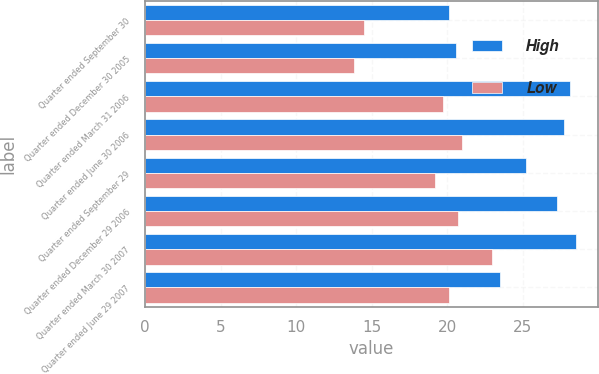Convert chart to OTSL. <chart><loc_0><loc_0><loc_500><loc_500><stacked_bar_chart><ecel><fcel>Quarter ended September 30<fcel>Quarter ended December 30 2005<fcel>Quarter ended March 31 2006<fcel>Quarter ended June 30 2006<fcel>Quarter ended September 29<fcel>Quarter ended December 29 2006<fcel>Quarter ended March 30 2007<fcel>Quarter ended June 29 2007<nl><fcel>High<fcel>20.08<fcel>20.54<fcel>28.11<fcel>27.74<fcel>25.2<fcel>27.27<fcel>28.51<fcel>23.47<nl><fcel>Low<fcel>14.5<fcel>13.82<fcel>19.69<fcel>20.94<fcel>19.15<fcel>20.73<fcel>22.94<fcel>20.1<nl></chart> 